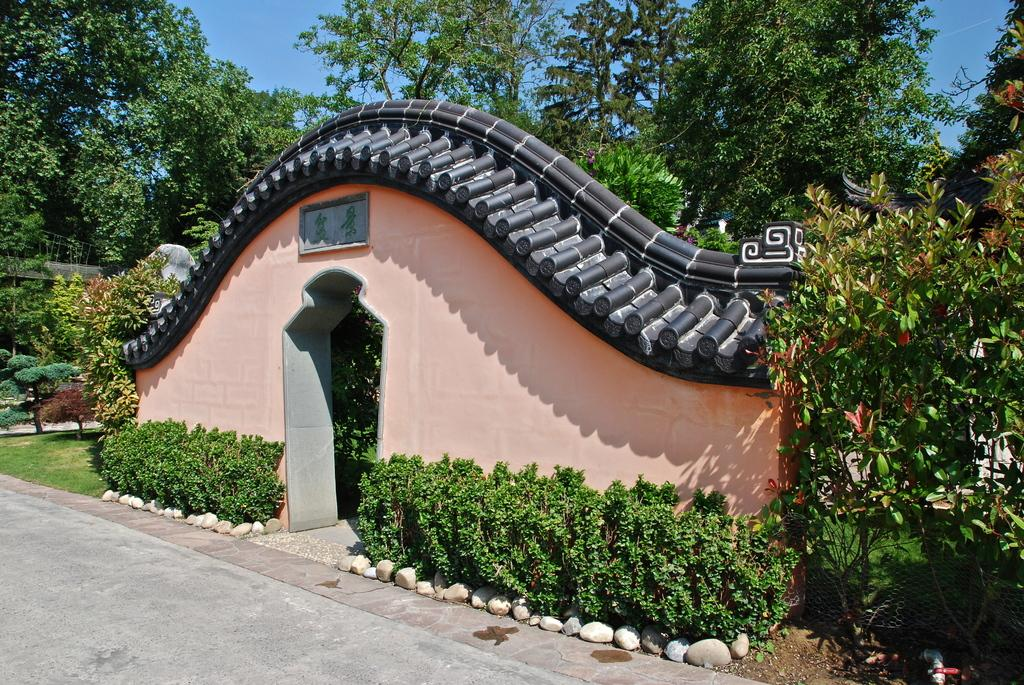What type of surface is visible in the image? There is a pavement in the image. What other natural elements can be seen in the image? There are plants in the image. What type of man-made structure is present in the image? There is an architectural structure in the image. What can be seen in the background of the image? There are trees and the sky visible in the background of the image. What type of liquid is being poured by the uncle in the image? There is no uncle present in the image, and therefore no such action can be observed. 